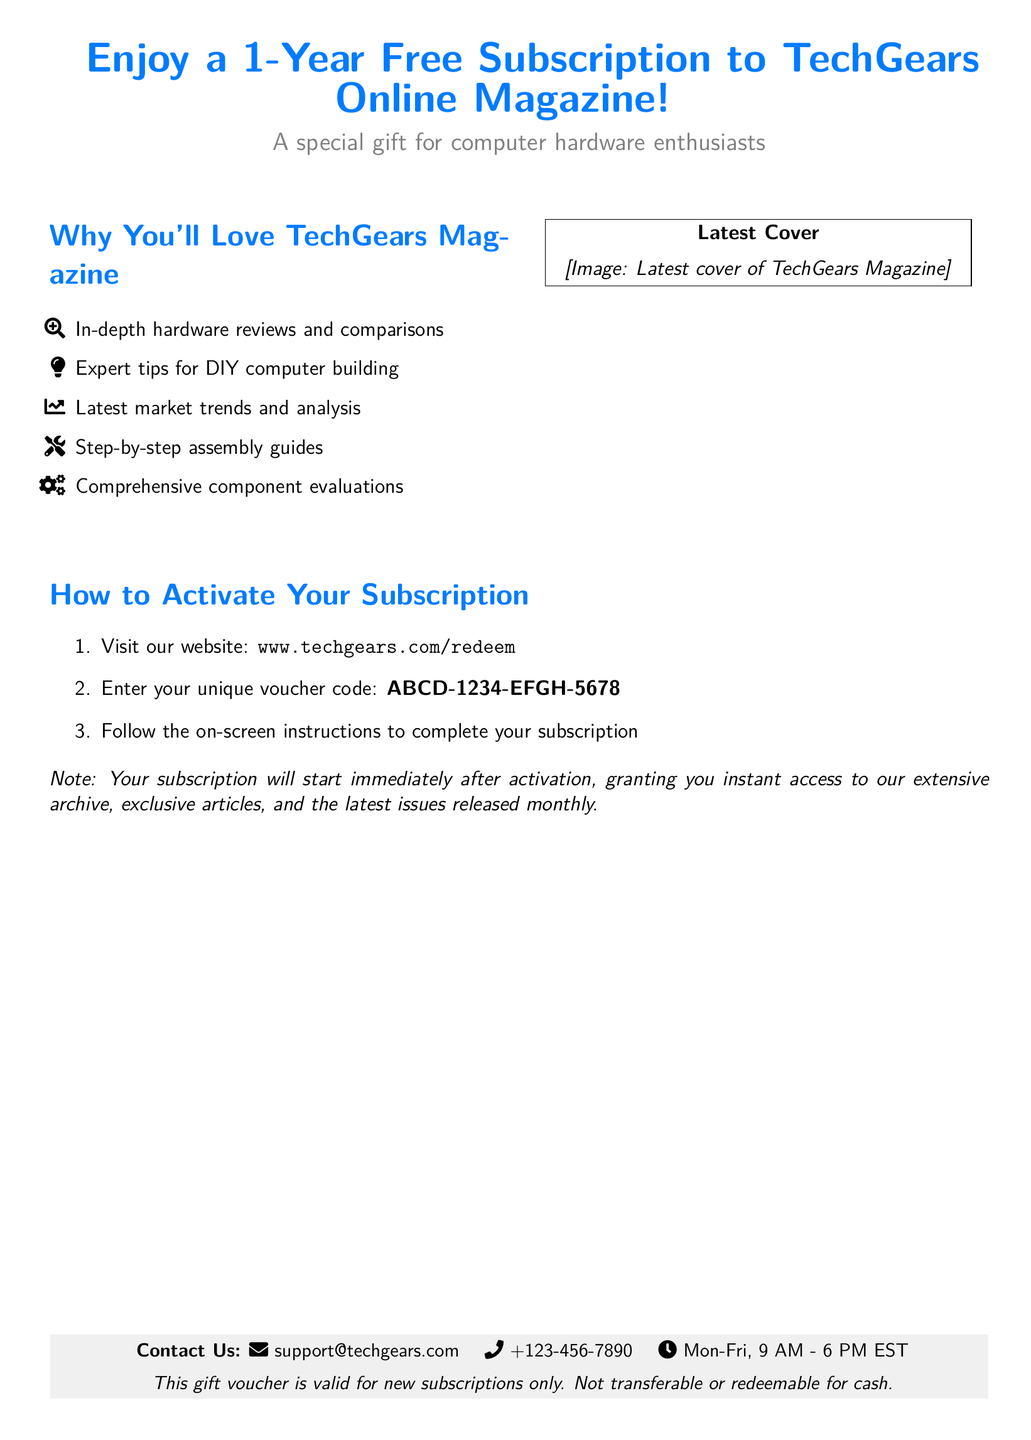What magazine is offered in the voucher? The document specifies that the voucher is for a subscription to TechGears Online Magazine.
Answer: TechGears Online Magazine How long is the subscription valid for? The document states that the subscription is for a duration of one year.
Answer: 1 year What is the unique voucher code to activate the subscription? The document provides the unique voucher code as part of the instructions to activate the subscription.
Answer: ABCD-1234-EFGH-5678 What is the website for redeeming the voucher? The document instructs users to visit a specific website to activate their subscription.
Answer: www.techgears.com/redeem What type of content can subscribers expect from TechGears Magazine? The document lists the types of content available, including in-depth hardware reviews and expert tips.
Answer: In-depth hardware reviews, expert tips When can users expect their subscription to start? The document notes that the subscription will start immediately after activation.
Answer: Immediately Which days are customer support available according to the document? The document explicitly mentions the working days for customer support under contact information.
Answer: Mon-Fri Can the gift voucher be transferred or redeemed for cash? The document clearly states the conditions regarding the voucher's transferability and cash redemption.
Answer: No 